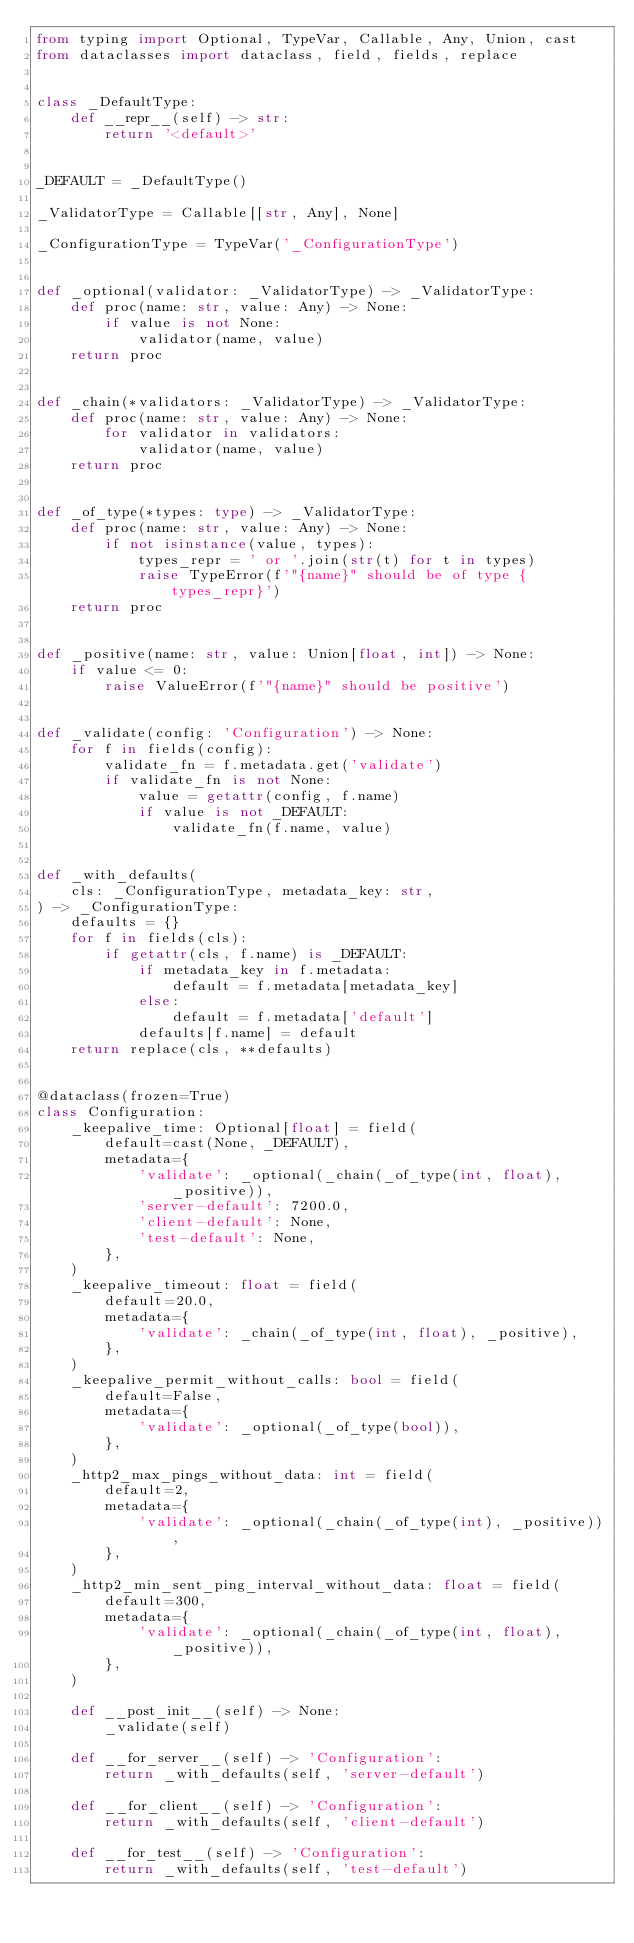Convert code to text. <code><loc_0><loc_0><loc_500><loc_500><_Python_>from typing import Optional, TypeVar, Callable, Any, Union, cast
from dataclasses import dataclass, field, fields, replace


class _DefaultType:
    def __repr__(self) -> str:
        return '<default>'


_DEFAULT = _DefaultType()

_ValidatorType = Callable[[str, Any], None]

_ConfigurationType = TypeVar('_ConfigurationType')


def _optional(validator: _ValidatorType) -> _ValidatorType:
    def proc(name: str, value: Any) -> None:
        if value is not None:
            validator(name, value)
    return proc


def _chain(*validators: _ValidatorType) -> _ValidatorType:
    def proc(name: str, value: Any) -> None:
        for validator in validators:
            validator(name, value)
    return proc


def _of_type(*types: type) -> _ValidatorType:
    def proc(name: str, value: Any) -> None:
        if not isinstance(value, types):
            types_repr = ' or '.join(str(t) for t in types)
            raise TypeError(f'"{name}" should be of type {types_repr}')
    return proc


def _positive(name: str, value: Union[float, int]) -> None:
    if value <= 0:
        raise ValueError(f'"{name}" should be positive')


def _validate(config: 'Configuration') -> None:
    for f in fields(config):
        validate_fn = f.metadata.get('validate')
        if validate_fn is not None:
            value = getattr(config, f.name)
            if value is not _DEFAULT:
                validate_fn(f.name, value)


def _with_defaults(
    cls: _ConfigurationType, metadata_key: str,
) -> _ConfigurationType:
    defaults = {}
    for f in fields(cls):
        if getattr(cls, f.name) is _DEFAULT:
            if metadata_key in f.metadata:
                default = f.metadata[metadata_key]
            else:
                default = f.metadata['default']
            defaults[f.name] = default
    return replace(cls, **defaults)


@dataclass(frozen=True)
class Configuration:
    _keepalive_time: Optional[float] = field(
        default=cast(None, _DEFAULT),
        metadata={
            'validate': _optional(_chain(_of_type(int, float), _positive)),
            'server-default': 7200.0,
            'client-default': None,
            'test-default': None,
        },
    )
    _keepalive_timeout: float = field(
        default=20.0,
        metadata={
            'validate': _chain(_of_type(int, float), _positive),
        },
    )
    _keepalive_permit_without_calls: bool = field(
        default=False,
        metadata={
            'validate': _optional(_of_type(bool)),
        },
    )
    _http2_max_pings_without_data: int = field(
        default=2,
        metadata={
            'validate': _optional(_chain(_of_type(int), _positive)),
        },
    )
    _http2_min_sent_ping_interval_without_data: float = field(
        default=300,
        metadata={
            'validate': _optional(_chain(_of_type(int, float), _positive)),
        },
    )

    def __post_init__(self) -> None:
        _validate(self)

    def __for_server__(self) -> 'Configuration':
        return _with_defaults(self, 'server-default')

    def __for_client__(self) -> 'Configuration':
        return _with_defaults(self, 'client-default')

    def __for_test__(self) -> 'Configuration':
        return _with_defaults(self, 'test-default')
</code> 